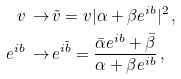<formula> <loc_0><loc_0><loc_500><loc_500>v \, \rightarrow \, & \tilde { v } = v | \alpha + \beta e ^ { i b } | ^ { 2 } \, , \\ e ^ { i b } \, \rightarrow \, & e ^ { i \tilde { b } } = \frac { \bar { \alpha } e ^ { i b } + \bar { \beta } } { \alpha + \beta e ^ { i b } } \, ,</formula> 